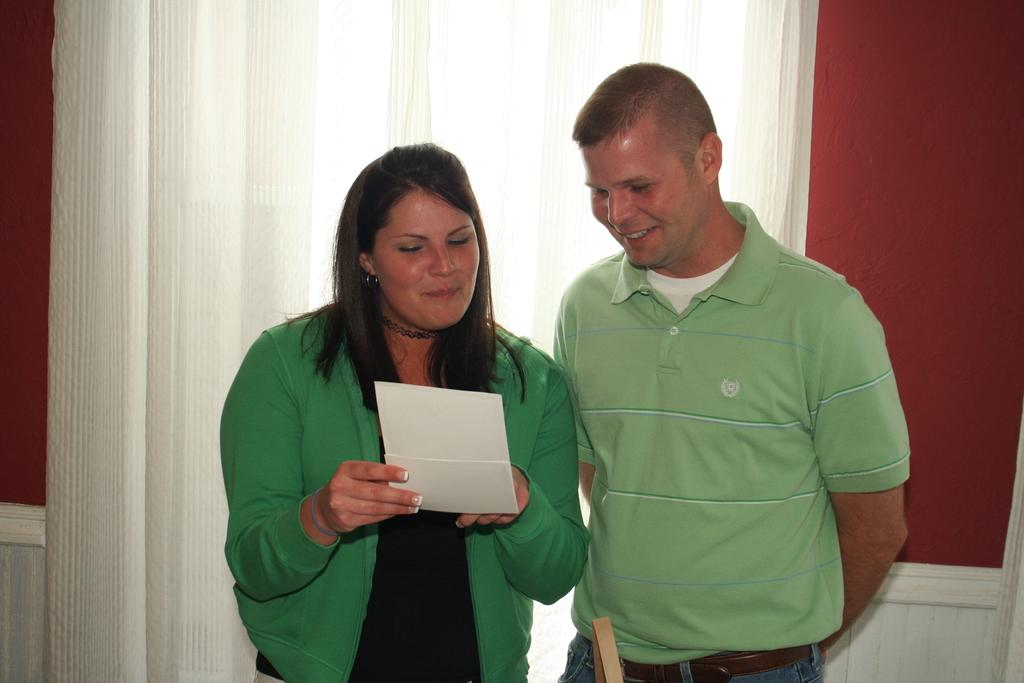What is the woman in the image holding? The woman is holding a paper with her hands. What is the facial expression of the woman in the image? The woman is smiling. Who else is present in the image? There is a man in the image. What is the facial expression of the man in the image? The man is smiling. What can be seen in the background of the image? There are curtains and a wall in the background of the image. What type of punishment is the baby receiving in the image? There is no baby present in the image, so it is not possible to determine if any punishment is being received. 